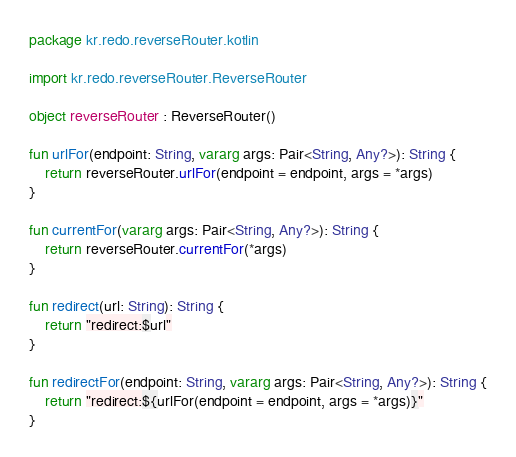Convert code to text. <code><loc_0><loc_0><loc_500><loc_500><_Kotlin_>package kr.redo.reverseRouter.kotlin

import kr.redo.reverseRouter.ReverseRouter

object reverseRouter : ReverseRouter()

fun urlFor(endpoint: String, vararg args: Pair<String, Any?>): String {
    return reverseRouter.urlFor(endpoint = endpoint, args = *args)
}

fun currentFor(vararg args: Pair<String, Any?>): String {
    return reverseRouter.currentFor(*args)
}

fun redirect(url: String): String {
    return "redirect:$url"
}

fun redirectFor(endpoint: String, vararg args: Pair<String, Any?>): String {
    return "redirect:${urlFor(endpoint = endpoint, args = *args)}"
}</code> 